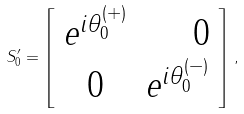<formula> <loc_0><loc_0><loc_500><loc_500>S _ { 0 } ^ { \prime } = \left [ \begin{array} { c r } e ^ { i \theta _ { 0 } ^ { ( + ) } } & 0 \\ 0 & e ^ { i \theta _ { 0 } ^ { ( - ) } } \end{array} \right ] \, ,</formula> 